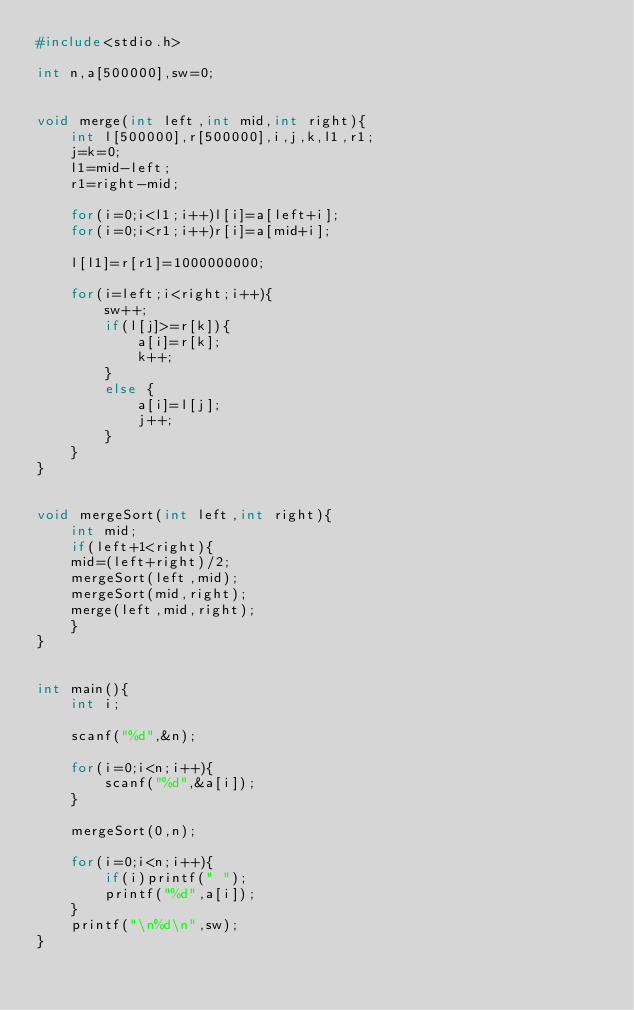Convert code to text. <code><loc_0><loc_0><loc_500><loc_500><_C++_>#include<stdio.h>

int n,a[500000],sw=0;


void merge(int left,int mid,int right){
    int l[500000],r[500000],i,j,k,l1,r1;
    j=k=0;
    l1=mid-left;
    r1=right-mid;

    for(i=0;i<l1;i++)l[i]=a[left+i];
    for(i=0;i<r1;i++)r[i]=a[mid+i];

    l[l1]=r[r1]=1000000000;

    for(i=left;i<right;i++){
        sw++;
        if(l[j]>=r[k]){
            a[i]=r[k];
            k++;
        }
        else {
            a[i]=l[j];
            j++;
        }
    }
}


void mergeSort(int left,int right){
    int mid;
    if(left+1<right){
    mid=(left+right)/2;
    mergeSort(left,mid);
    mergeSort(mid,right);
    merge(left,mid,right);
    }
}


int main(){
    int i;

    scanf("%d",&n);

    for(i=0;i<n;i++){
        scanf("%d",&a[i]);
    }

    mergeSort(0,n);

    for(i=0;i<n;i++){
        if(i)printf(" ");
        printf("%d",a[i]);
    }
    printf("\n%d\n",sw);
}
</code> 